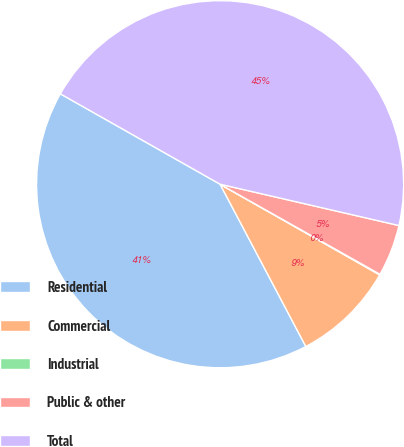Convert chart to OTSL. <chart><loc_0><loc_0><loc_500><loc_500><pie_chart><fcel>Residential<fcel>Commercial<fcel>Industrial<fcel>Public & other<fcel>Total<nl><fcel>40.93%<fcel>9.04%<fcel>0.06%<fcel>4.55%<fcel>45.42%<nl></chart> 